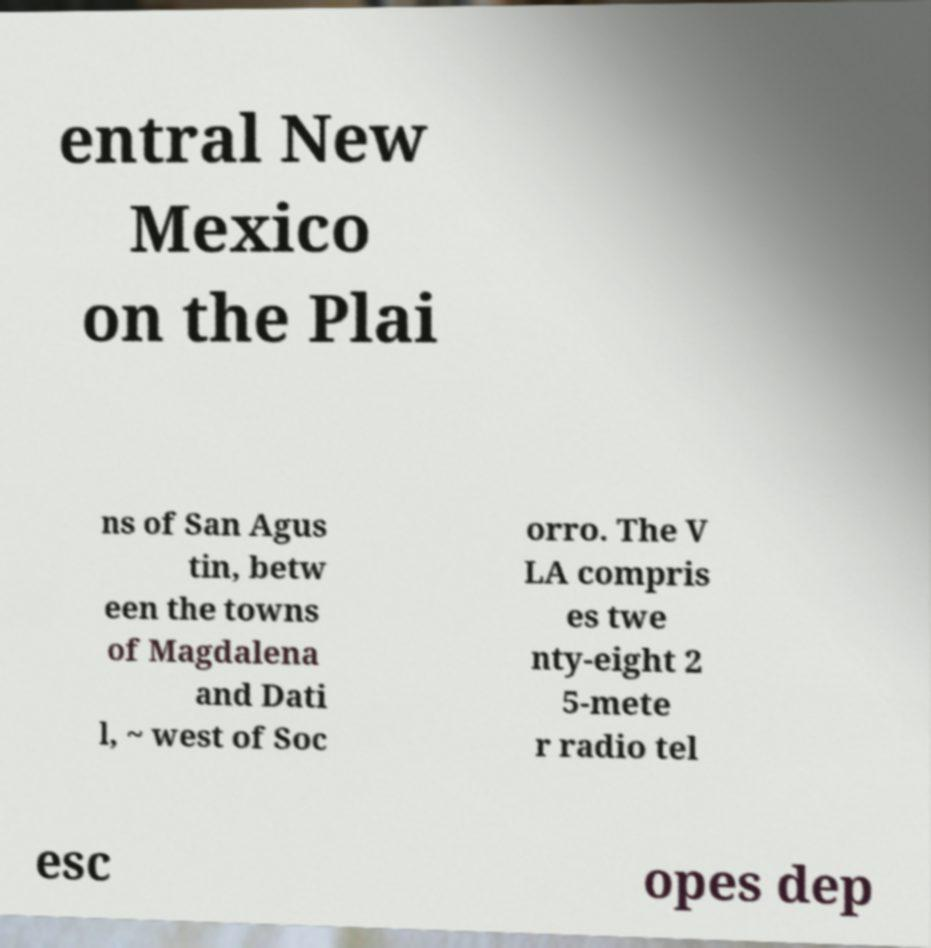Please read and relay the text visible in this image. What does it say? entral New Mexico on the Plai ns of San Agus tin, betw een the towns of Magdalena and Dati l, ~ west of Soc orro. The V LA compris es twe nty-eight 2 5-mete r radio tel esc opes dep 